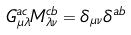Convert formula to latex. <formula><loc_0><loc_0><loc_500><loc_500>G _ { \mu \lambda } ^ { a c } M _ { \lambda \nu } ^ { c b } = \delta _ { \mu \nu } \delta ^ { a b }</formula> 